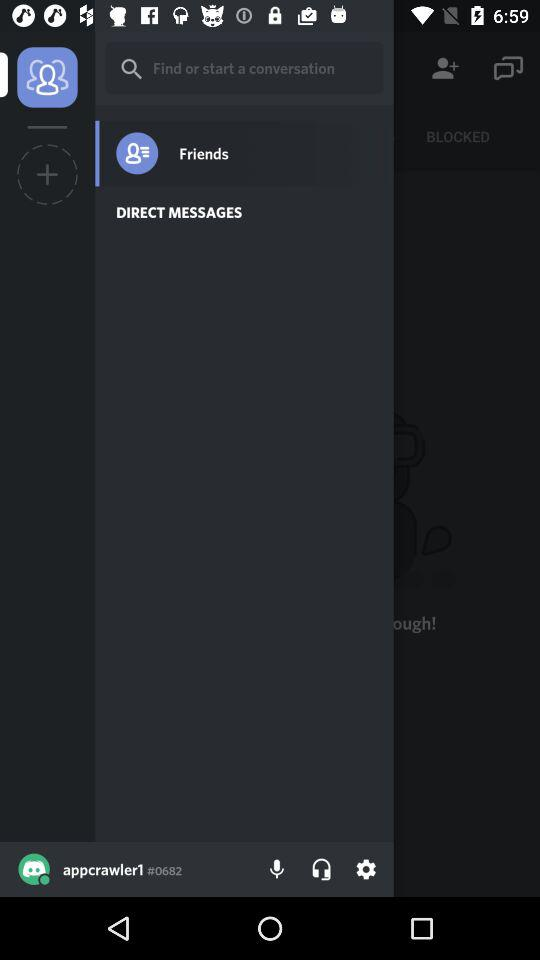What is the username? The username is "appcrawler1". 